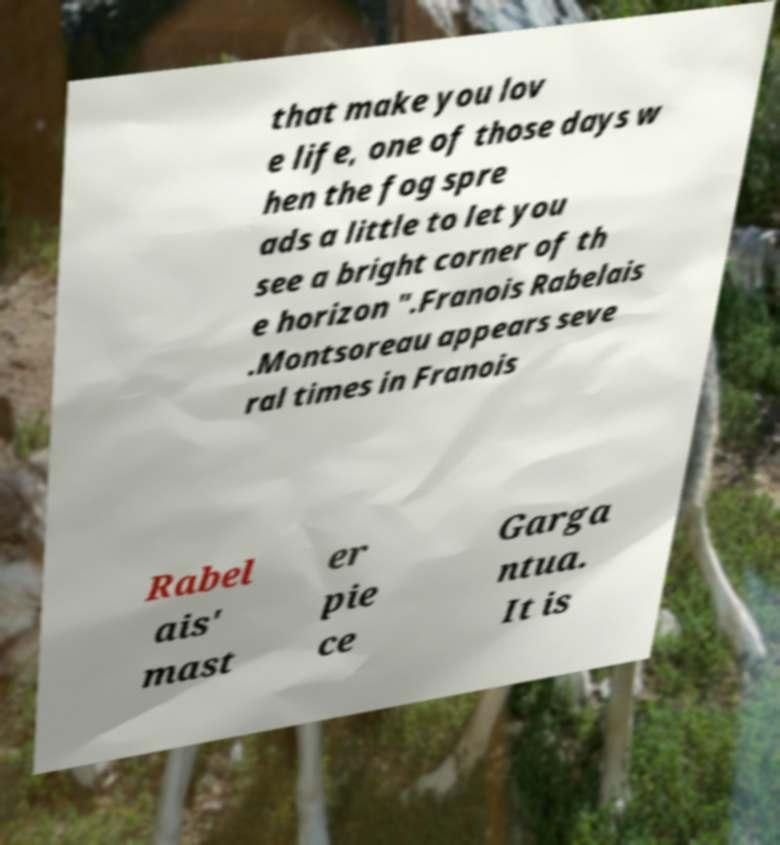Please identify and transcribe the text found in this image. that make you lov e life, one of those days w hen the fog spre ads a little to let you see a bright corner of th e horizon ".Franois Rabelais .Montsoreau appears seve ral times in Franois Rabel ais' mast er pie ce Garga ntua. It is 